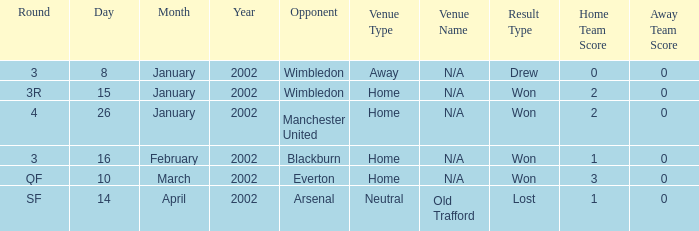On which date does a round with sf occur? 14 April 2002. 